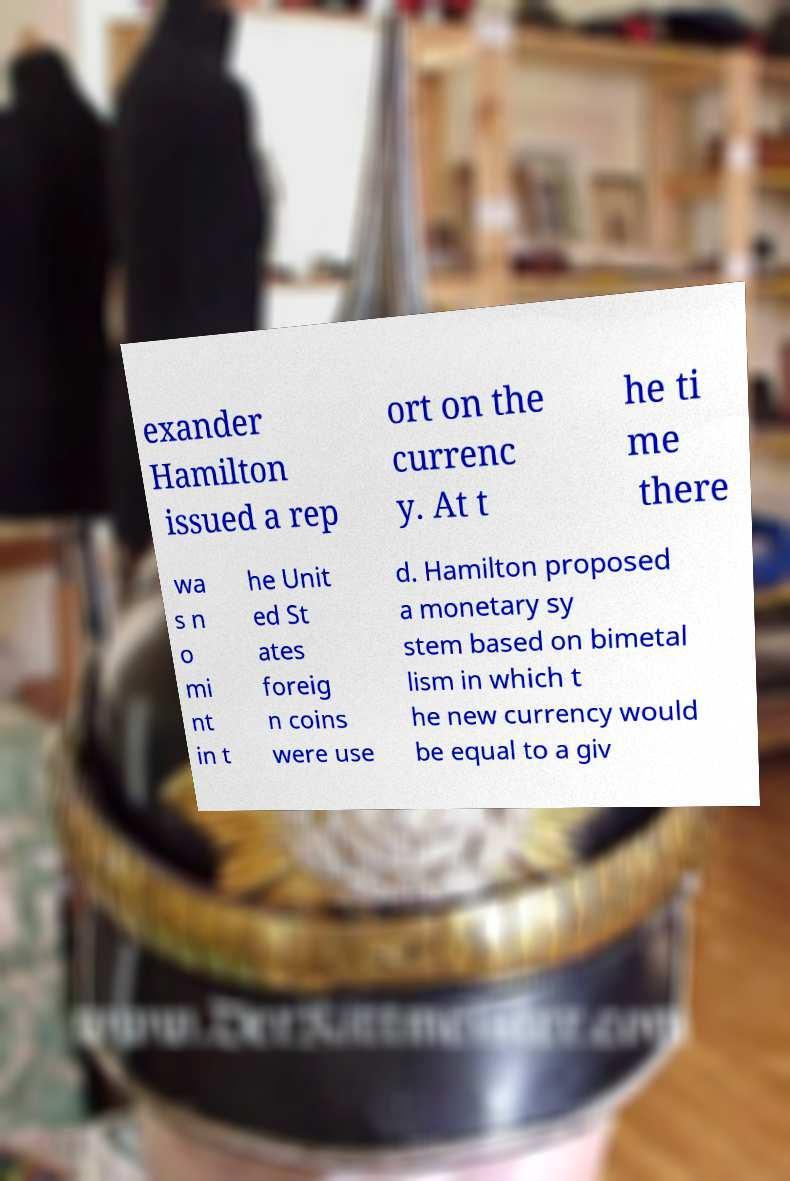Can you accurately transcribe the text from the provided image for me? exander Hamilton issued a rep ort on the currenc y. At t he ti me there wa s n o mi nt in t he Unit ed St ates foreig n coins were use d. Hamilton proposed a monetary sy stem based on bimetal lism in which t he new currency would be equal to a giv 